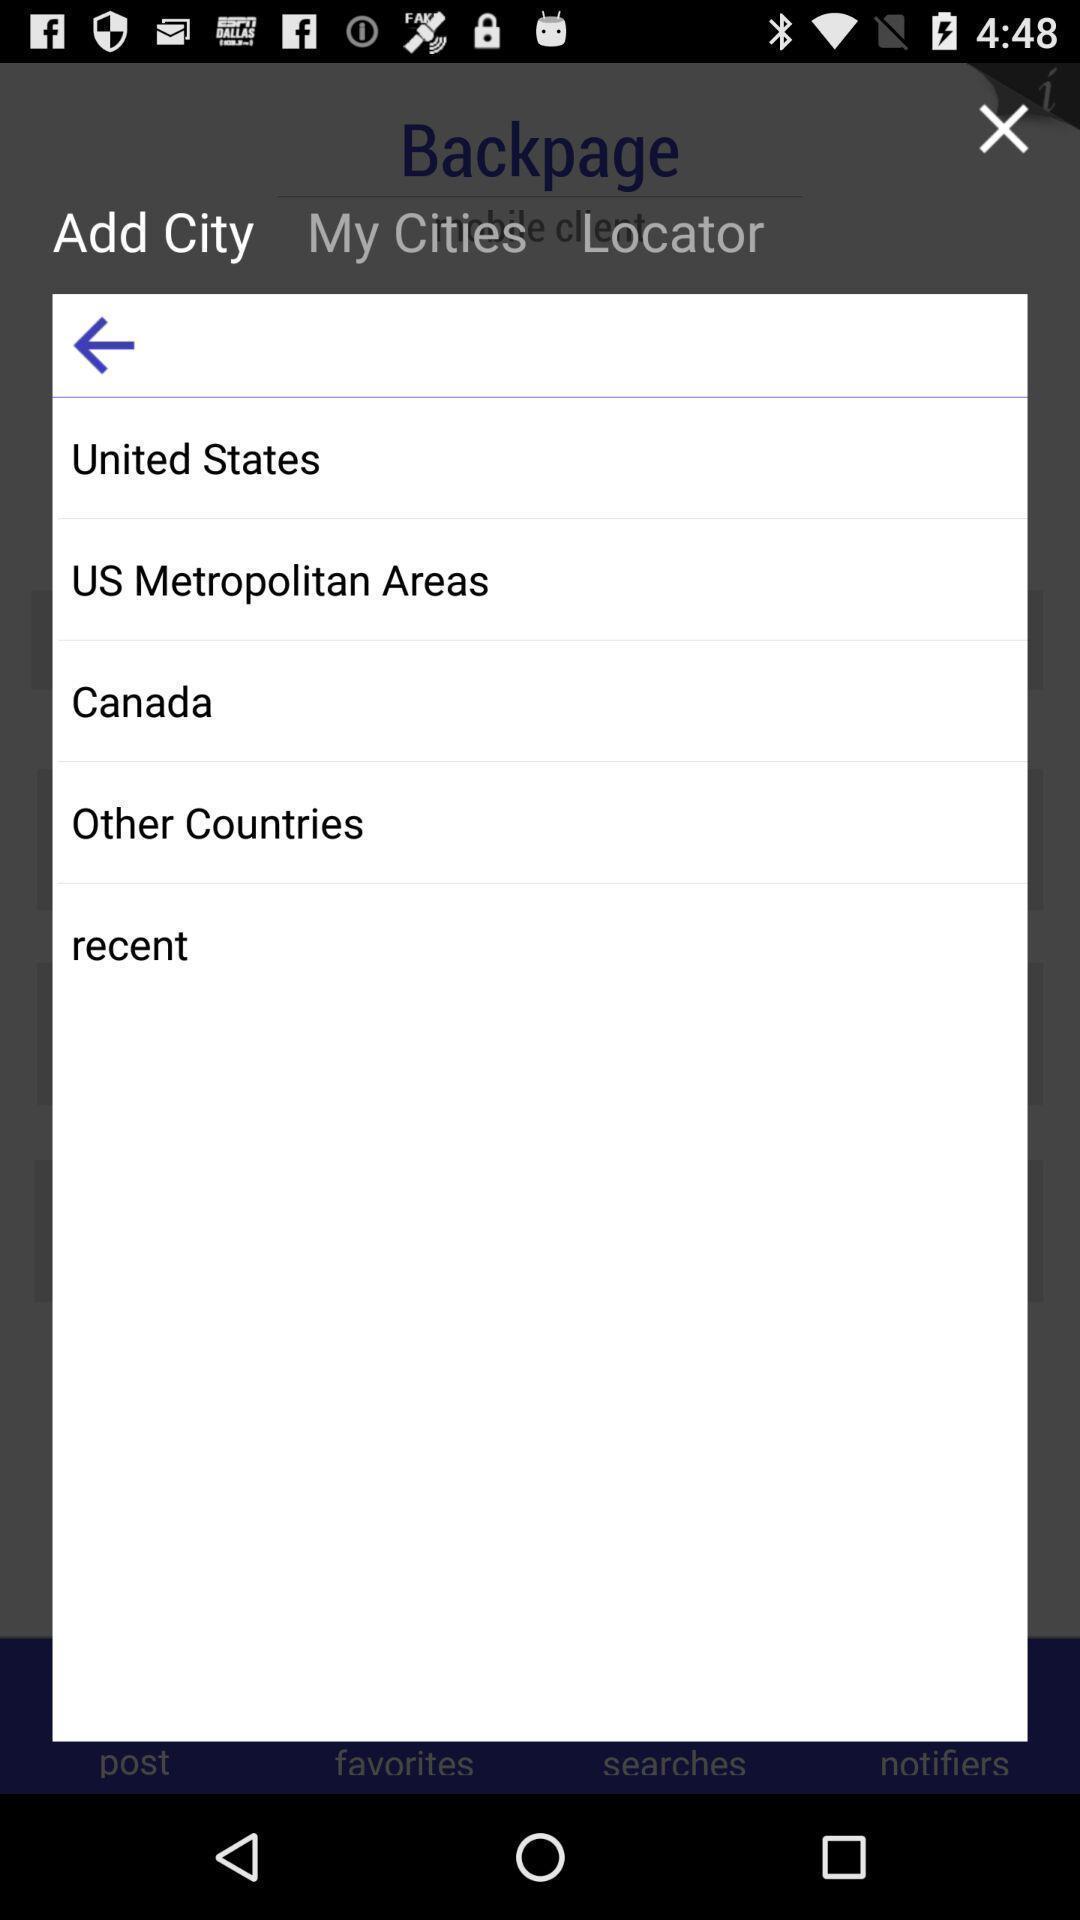What is the overall content of this screenshot? Pop up showing list of countries. 